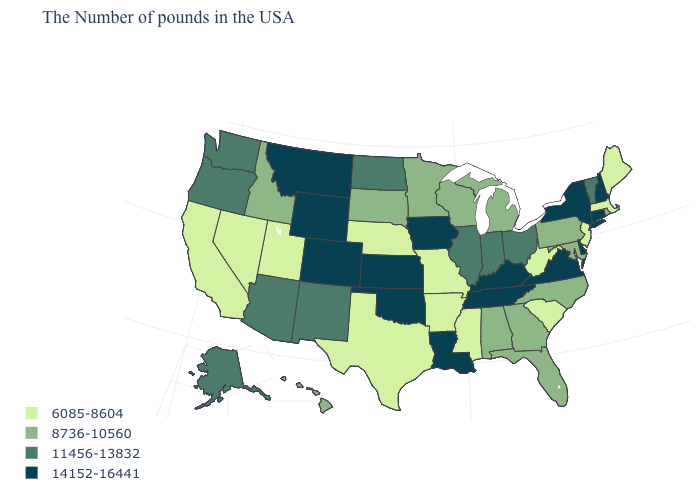Does New Hampshire have the highest value in the Northeast?
Concise answer only. Yes. Which states have the highest value in the USA?
Give a very brief answer. New Hampshire, Connecticut, New York, Delaware, Virginia, Kentucky, Tennessee, Louisiana, Iowa, Kansas, Oklahoma, Wyoming, Colorado, Montana. What is the lowest value in the USA?
Quick response, please. 6085-8604. What is the value of Connecticut?
Be succinct. 14152-16441. Does Massachusetts have a lower value than Virginia?
Quick response, please. Yes. Does Arkansas have the highest value in the South?
Answer briefly. No. Does Wyoming have a lower value than Oregon?
Answer briefly. No. What is the lowest value in states that border Tennessee?
Quick response, please. 6085-8604. Which states have the highest value in the USA?
Be succinct. New Hampshire, Connecticut, New York, Delaware, Virginia, Kentucky, Tennessee, Louisiana, Iowa, Kansas, Oklahoma, Wyoming, Colorado, Montana. Name the states that have a value in the range 8736-10560?
Keep it brief. Rhode Island, Maryland, Pennsylvania, North Carolina, Florida, Georgia, Michigan, Alabama, Wisconsin, Minnesota, South Dakota, Idaho, Hawaii. What is the value of Vermont?
Keep it brief. 11456-13832. What is the lowest value in the USA?
Keep it brief. 6085-8604. How many symbols are there in the legend?
Give a very brief answer. 4. Which states hav the highest value in the MidWest?
Quick response, please. Iowa, Kansas. What is the lowest value in states that border New Mexico?
Keep it brief. 6085-8604. 